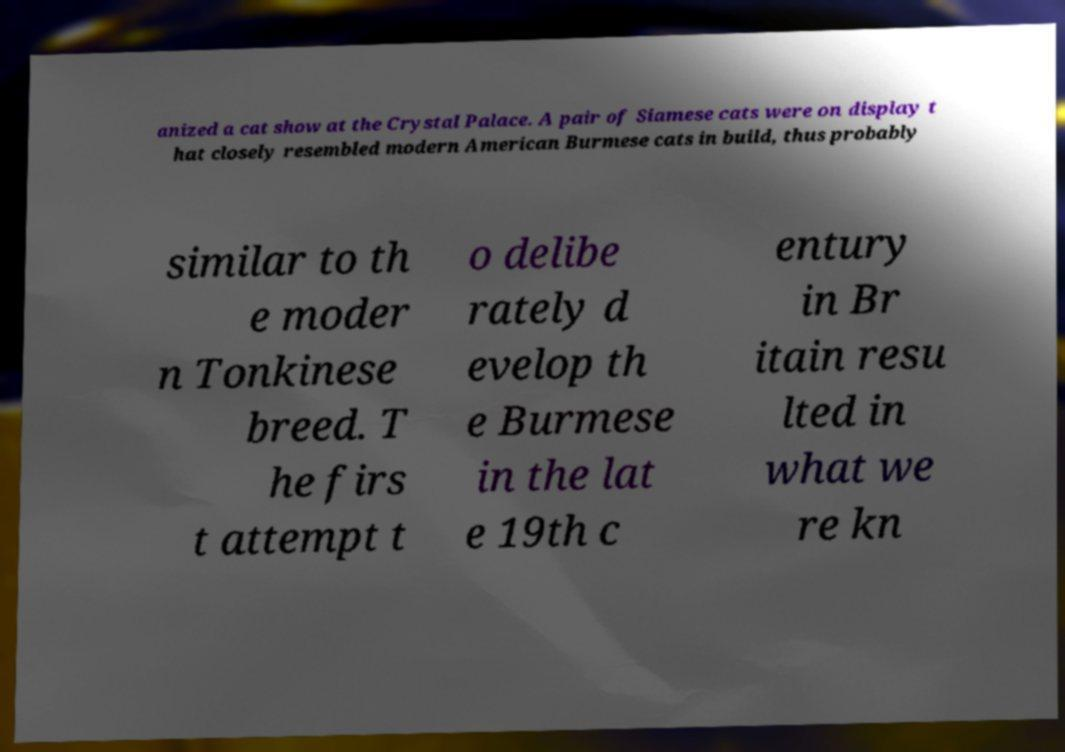Can you read and provide the text displayed in the image?This photo seems to have some interesting text. Can you extract and type it out for me? anized a cat show at the Crystal Palace. A pair of Siamese cats were on display t hat closely resembled modern American Burmese cats in build, thus probably similar to th e moder n Tonkinese breed. T he firs t attempt t o delibe rately d evelop th e Burmese in the lat e 19th c entury in Br itain resu lted in what we re kn 